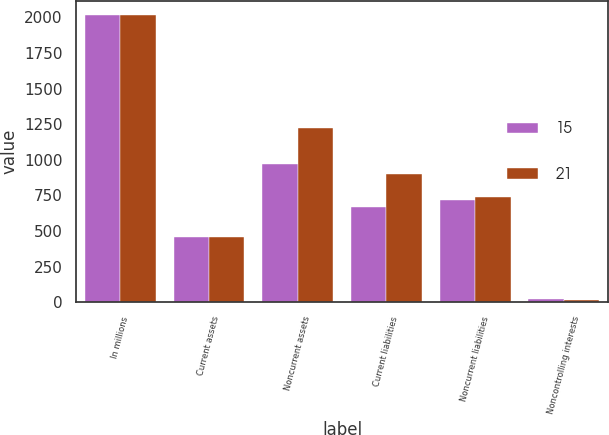<chart> <loc_0><loc_0><loc_500><loc_500><stacked_bar_chart><ecel><fcel>In millions<fcel>Current assets<fcel>Noncurrent assets<fcel>Current liabilities<fcel>Noncurrent liabilities<fcel>Noncontrolling interests<nl><fcel>15<fcel>2015<fcel>455<fcel>968<fcel>665<fcel>715<fcel>21<nl><fcel>21<fcel>2014<fcel>458<fcel>1223<fcel>899<fcel>742<fcel>15<nl></chart> 